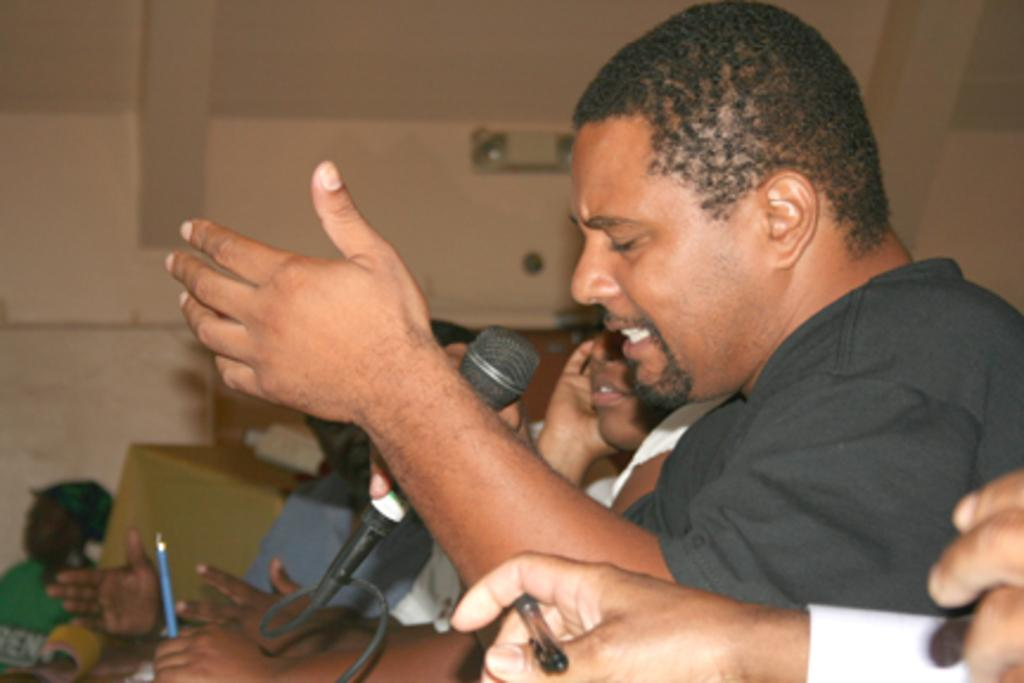Who is the main subject in the center of the picture? There is a person in the center of the picture. What is the person wearing? The person is wearing a black shirt. What is the person in the center doing? The person in the center is singing. Can you describe the hands visible on the right side of the image? There are visible hands on the right side of the image, but their specific actions cannot be determined from the provided facts. What can be seen in the background of the image? There are people and a wall in the background of the image. What type of cord is being used to power the wheel in the image? There is no wheel or cord present in the image. What time of day is depicted in the image? The provided facts do not mention the time of day, so it cannot be determined from the image. 